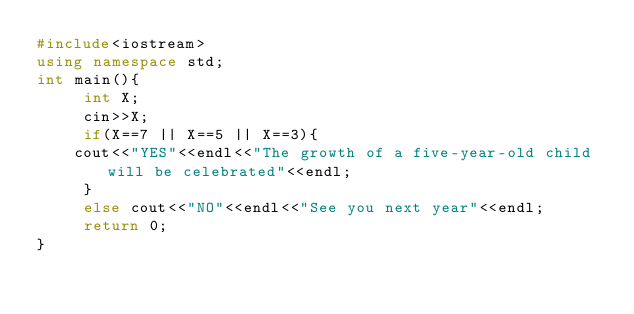Convert code to text. <code><loc_0><loc_0><loc_500><loc_500><_C++_>#include<iostream>
using namespace std;
int main(){
     int X;
     cin>>X;
     if(X==7 || X==5 || X==3){
    cout<<"YES"<<endl<<"The growth of a five-year-old child will be celebrated"<<endl;
     }
     else cout<<"NO"<<endl<<"See you next year"<<endl;
     return 0;
}</code> 